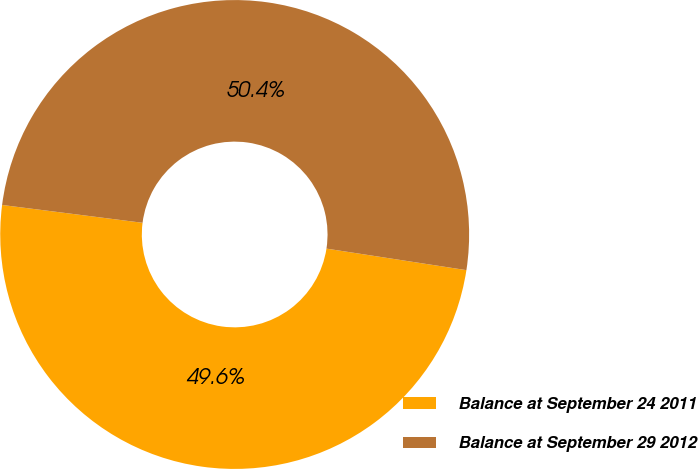Convert chart to OTSL. <chart><loc_0><loc_0><loc_500><loc_500><pie_chart><fcel>Balance at September 24 2011<fcel>Balance at September 29 2012<nl><fcel>49.58%<fcel>50.42%<nl></chart> 